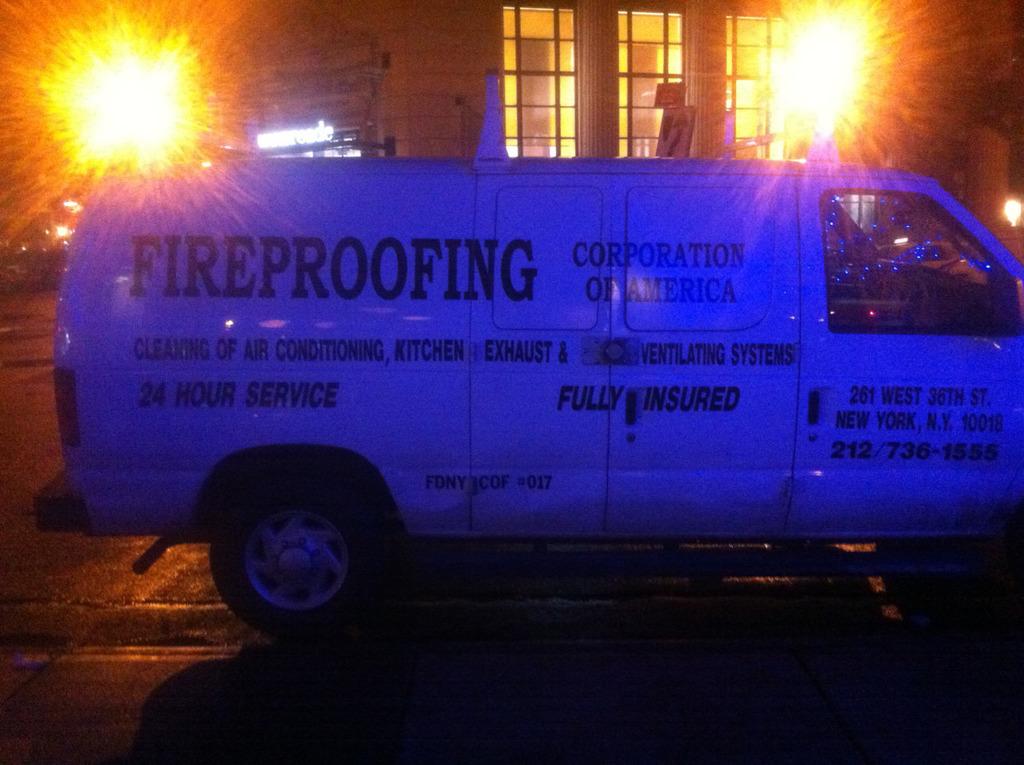What does the side of the van say?
Keep it short and to the point. Fireproofing. 